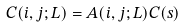Convert formula to latex. <formula><loc_0><loc_0><loc_500><loc_500>C ( i , j ; L ) = A ( i , j ; L ) C ( s )</formula> 